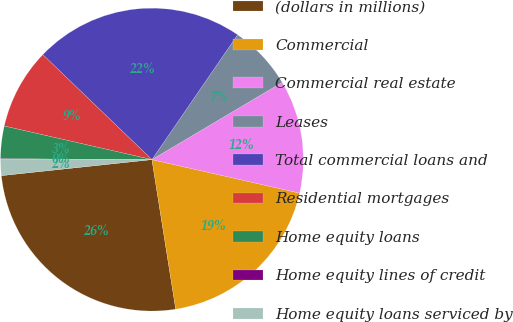<chart> <loc_0><loc_0><loc_500><loc_500><pie_chart><fcel>(dollars in millions)<fcel>Commercial<fcel>Commercial real estate<fcel>Leases<fcel>Total commercial loans and<fcel>Residential mortgages<fcel>Home equity loans<fcel>Home equity lines of credit<fcel>Home equity loans serviced by<nl><fcel>25.82%<fcel>18.94%<fcel>12.07%<fcel>6.91%<fcel>22.38%<fcel>8.63%<fcel>3.47%<fcel>0.03%<fcel>1.75%<nl></chart> 